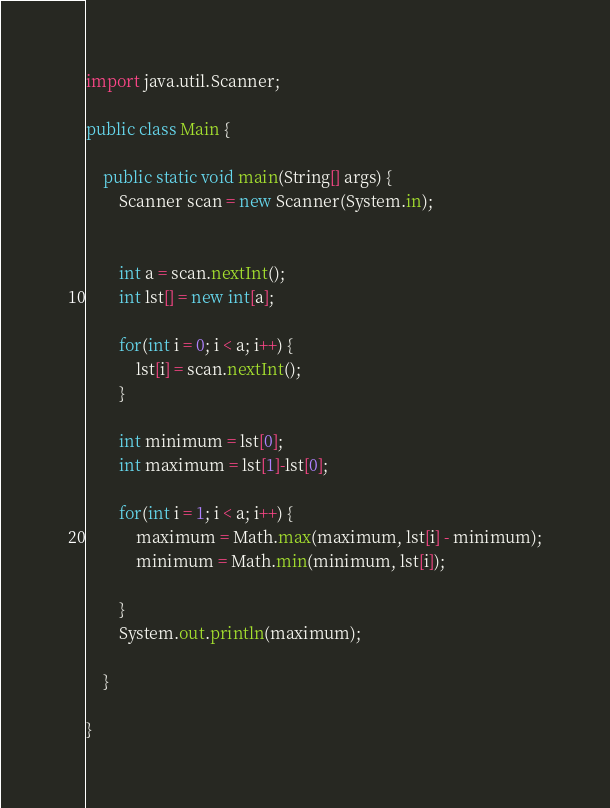Convert code to text. <code><loc_0><loc_0><loc_500><loc_500><_Java_>
import java.util.Scanner;

public class Main {
	
	public static void main(String[] args) {
		Scanner scan = new Scanner(System.in);
		
		
		int a = scan.nextInt();
		int lst[] = new int[a];
		
		for(int i = 0; i < a; i++) {
			lst[i] = scan.nextInt();
		}
		
		int minimum = lst[0];
		int maximum = lst[1]-lst[0];
		
		for(int i = 1; i < a; i++) {
			maximum = Math.max(maximum, lst[i] - minimum);
			minimum = Math.min(minimum, lst[i]);

		}
		System.out.println(maximum);
		
	}

}

</code> 